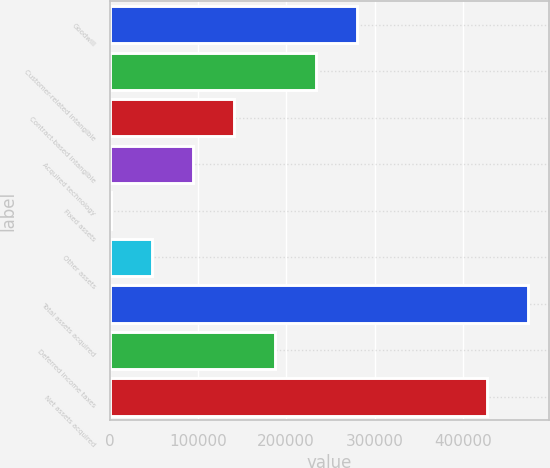Convert chart to OTSL. <chart><loc_0><loc_0><loc_500><loc_500><bar_chart><fcel>Goodwill<fcel>Customer-related intangible<fcel>Contract-based intangible<fcel>Acquired technology<fcel>Fixed assets<fcel>Other assets<fcel>Total assets acquired<fcel>Deferred income taxes<fcel>Net assets acquired<nl><fcel>280684<fcel>234184<fcel>141182<fcel>94681.4<fcel>1680<fcel>48180.7<fcel>474239<fcel>187683<fcel>427738<nl></chart> 